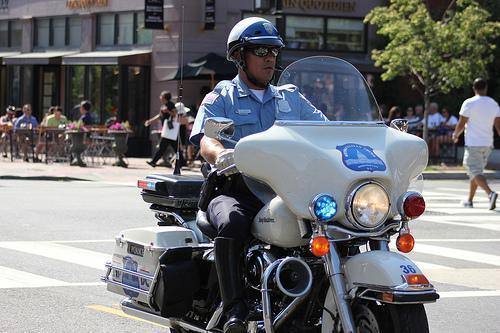How many motorcycles are there?
Give a very brief answer. 1. How many people are wearing a helmet in the picture?
Give a very brief answer. 1. 